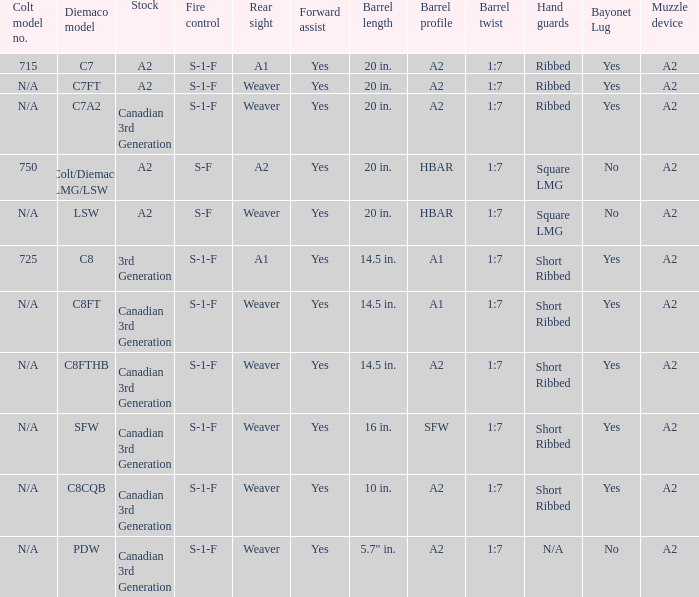Which hand guards feature an a2 barrel profile and are equipped with a weaver rear sight? Ribbed, Ribbed, Short Ribbed, Short Ribbed, N/A. 